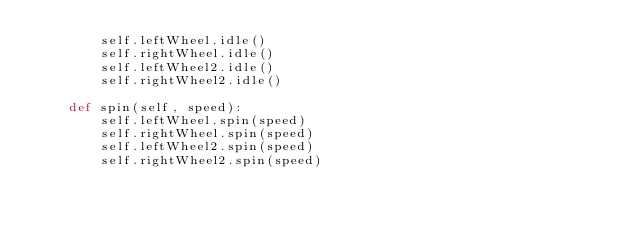<code> <loc_0><loc_0><loc_500><loc_500><_Python_>        self.leftWheel.idle()
        self.rightWheel.idle()
        self.leftWheel2.idle()
        self.rightWheel2.idle()
        
    def spin(self, speed):
        self.leftWheel.spin(speed)
        self.rightWheel.spin(speed)        
        self.leftWheel2.spin(speed)
        self.rightWheel2.spin(speed)        
        
</code> 